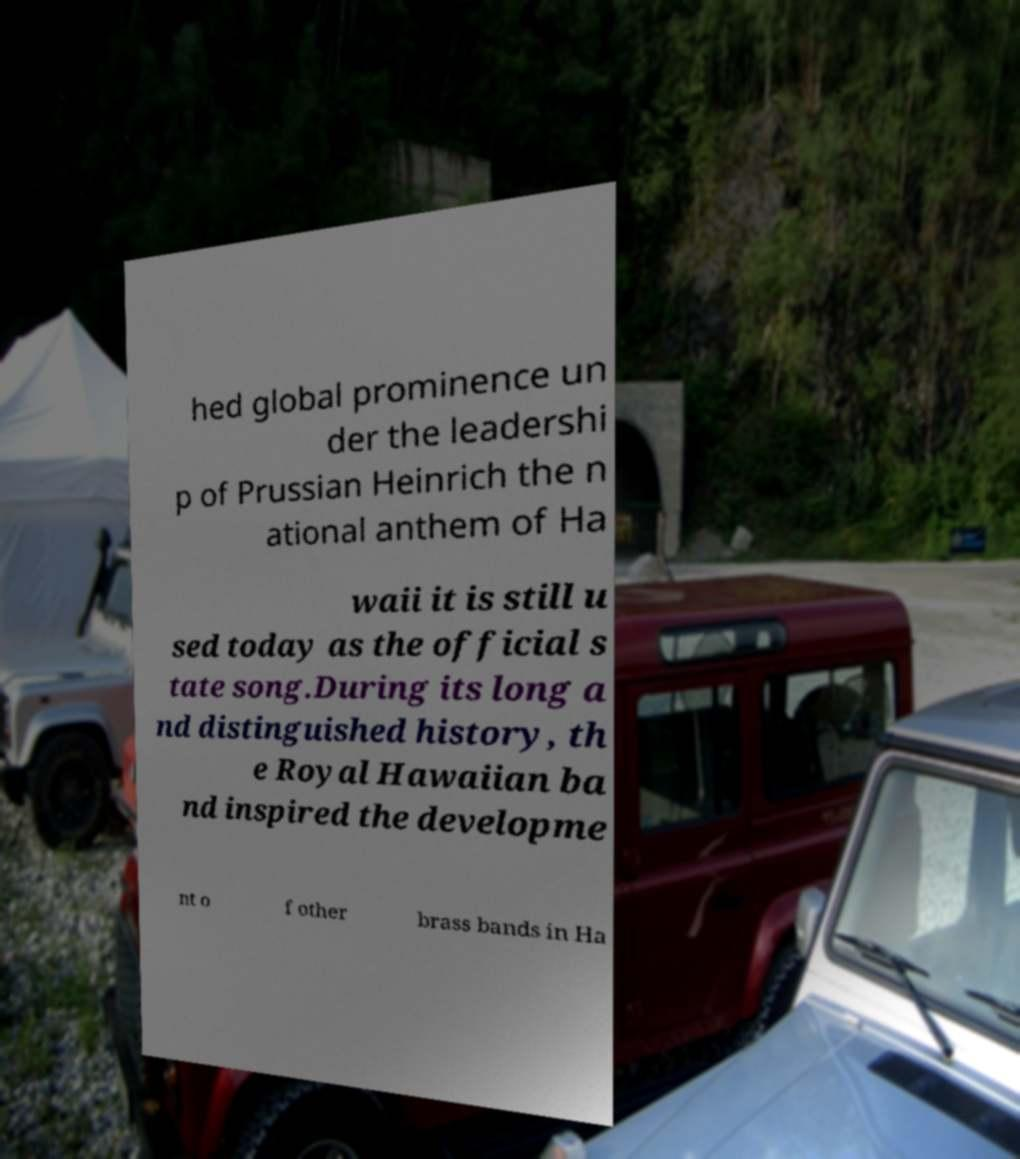Please read and relay the text visible in this image. What does it say? hed global prominence un der the leadershi p of Prussian Heinrich the n ational anthem of Ha waii it is still u sed today as the official s tate song.During its long a nd distinguished history, th e Royal Hawaiian ba nd inspired the developme nt o f other brass bands in Ha 